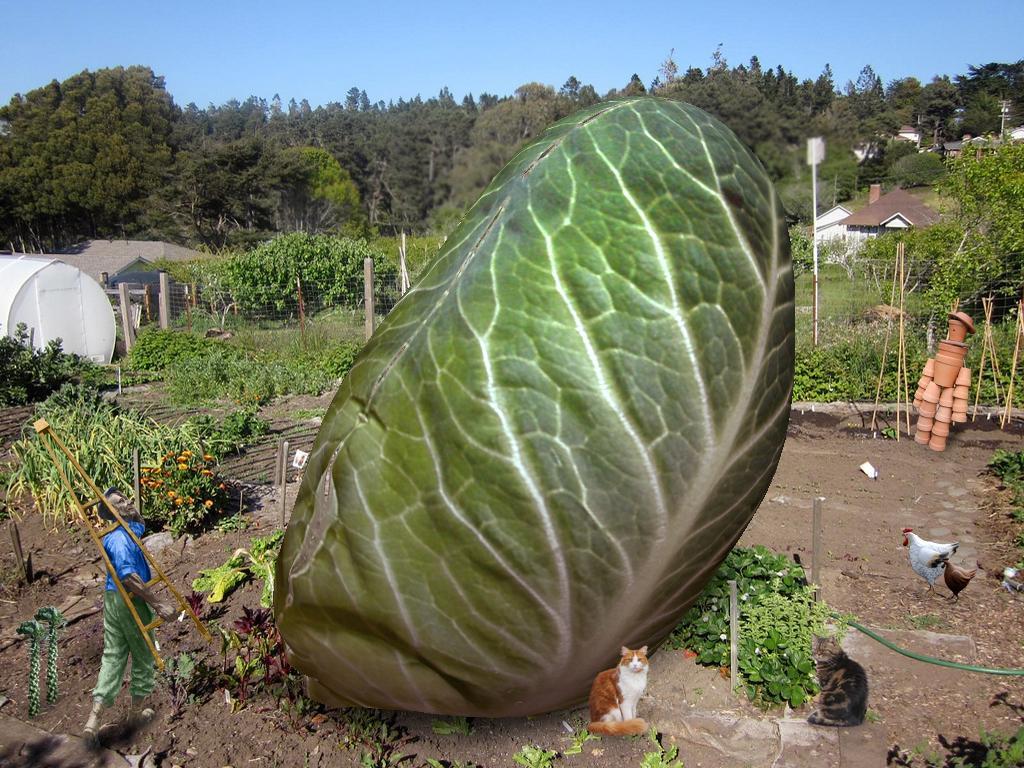Describe this image in one or two sentences. In this image there is a cabbage on the surface, in front of the cabbage there are two hens and two cats and there is a person walking by holding a ladder, in the background of the image there are trees and houses, to the left of the cabbage there are plants and bushes on the surface. 